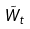<formula> <loc_0><loc_0><loc_500><loc_500>\tilde { W } _ { t }</formula> 